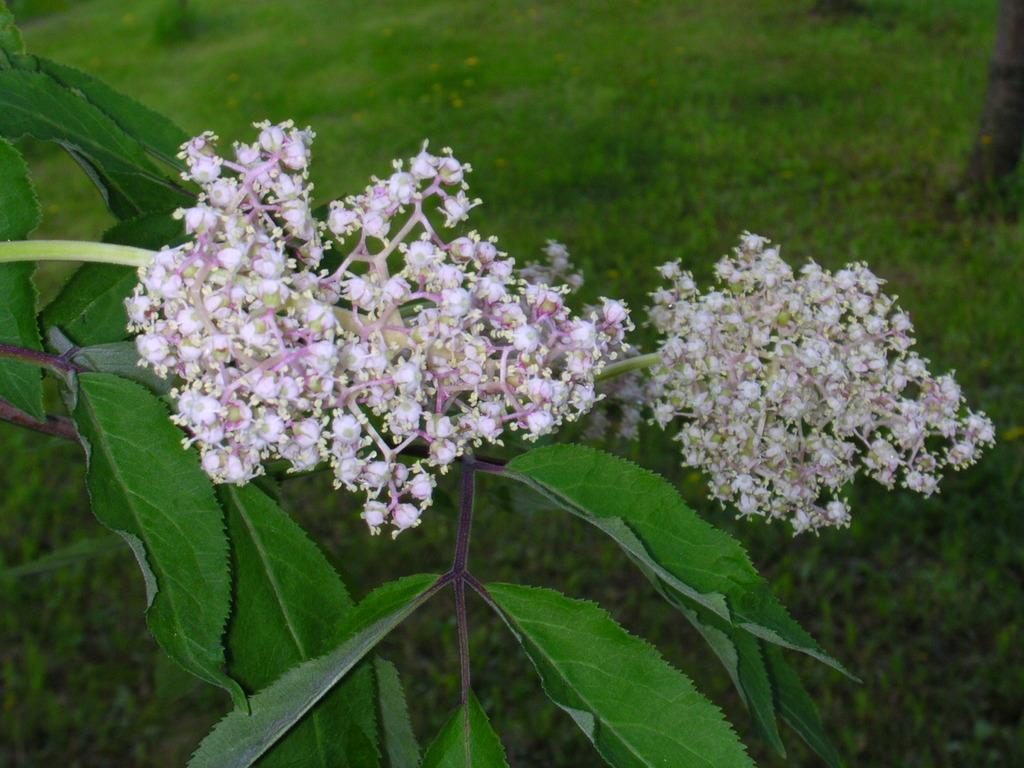What type of plant is visible in the image? There are flowers on a plant in the image. What is the ground covered with in the image? The ground is covered with grass in the image. What type of ring can be seen on the corn in the image? There is no corn or ring present in the image; it features a plant with flowers and grass-covered ground. 